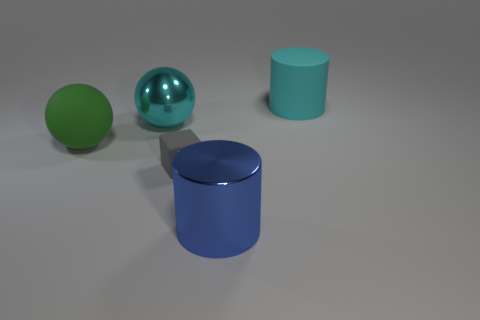Add 1 green rubber things. How many objects exist? 6 Subtract all blocks. How many objects are left? 4 Subtract 0 brown cylinders. How many objects are left? 5 Subtract all cyan objects. Subtract all small gray things. How many objects are left? 2 Add 5 matte objects. How many matte objects are left? 8 Add 3 green rubber objects. How many green rubber objects exist? 4 